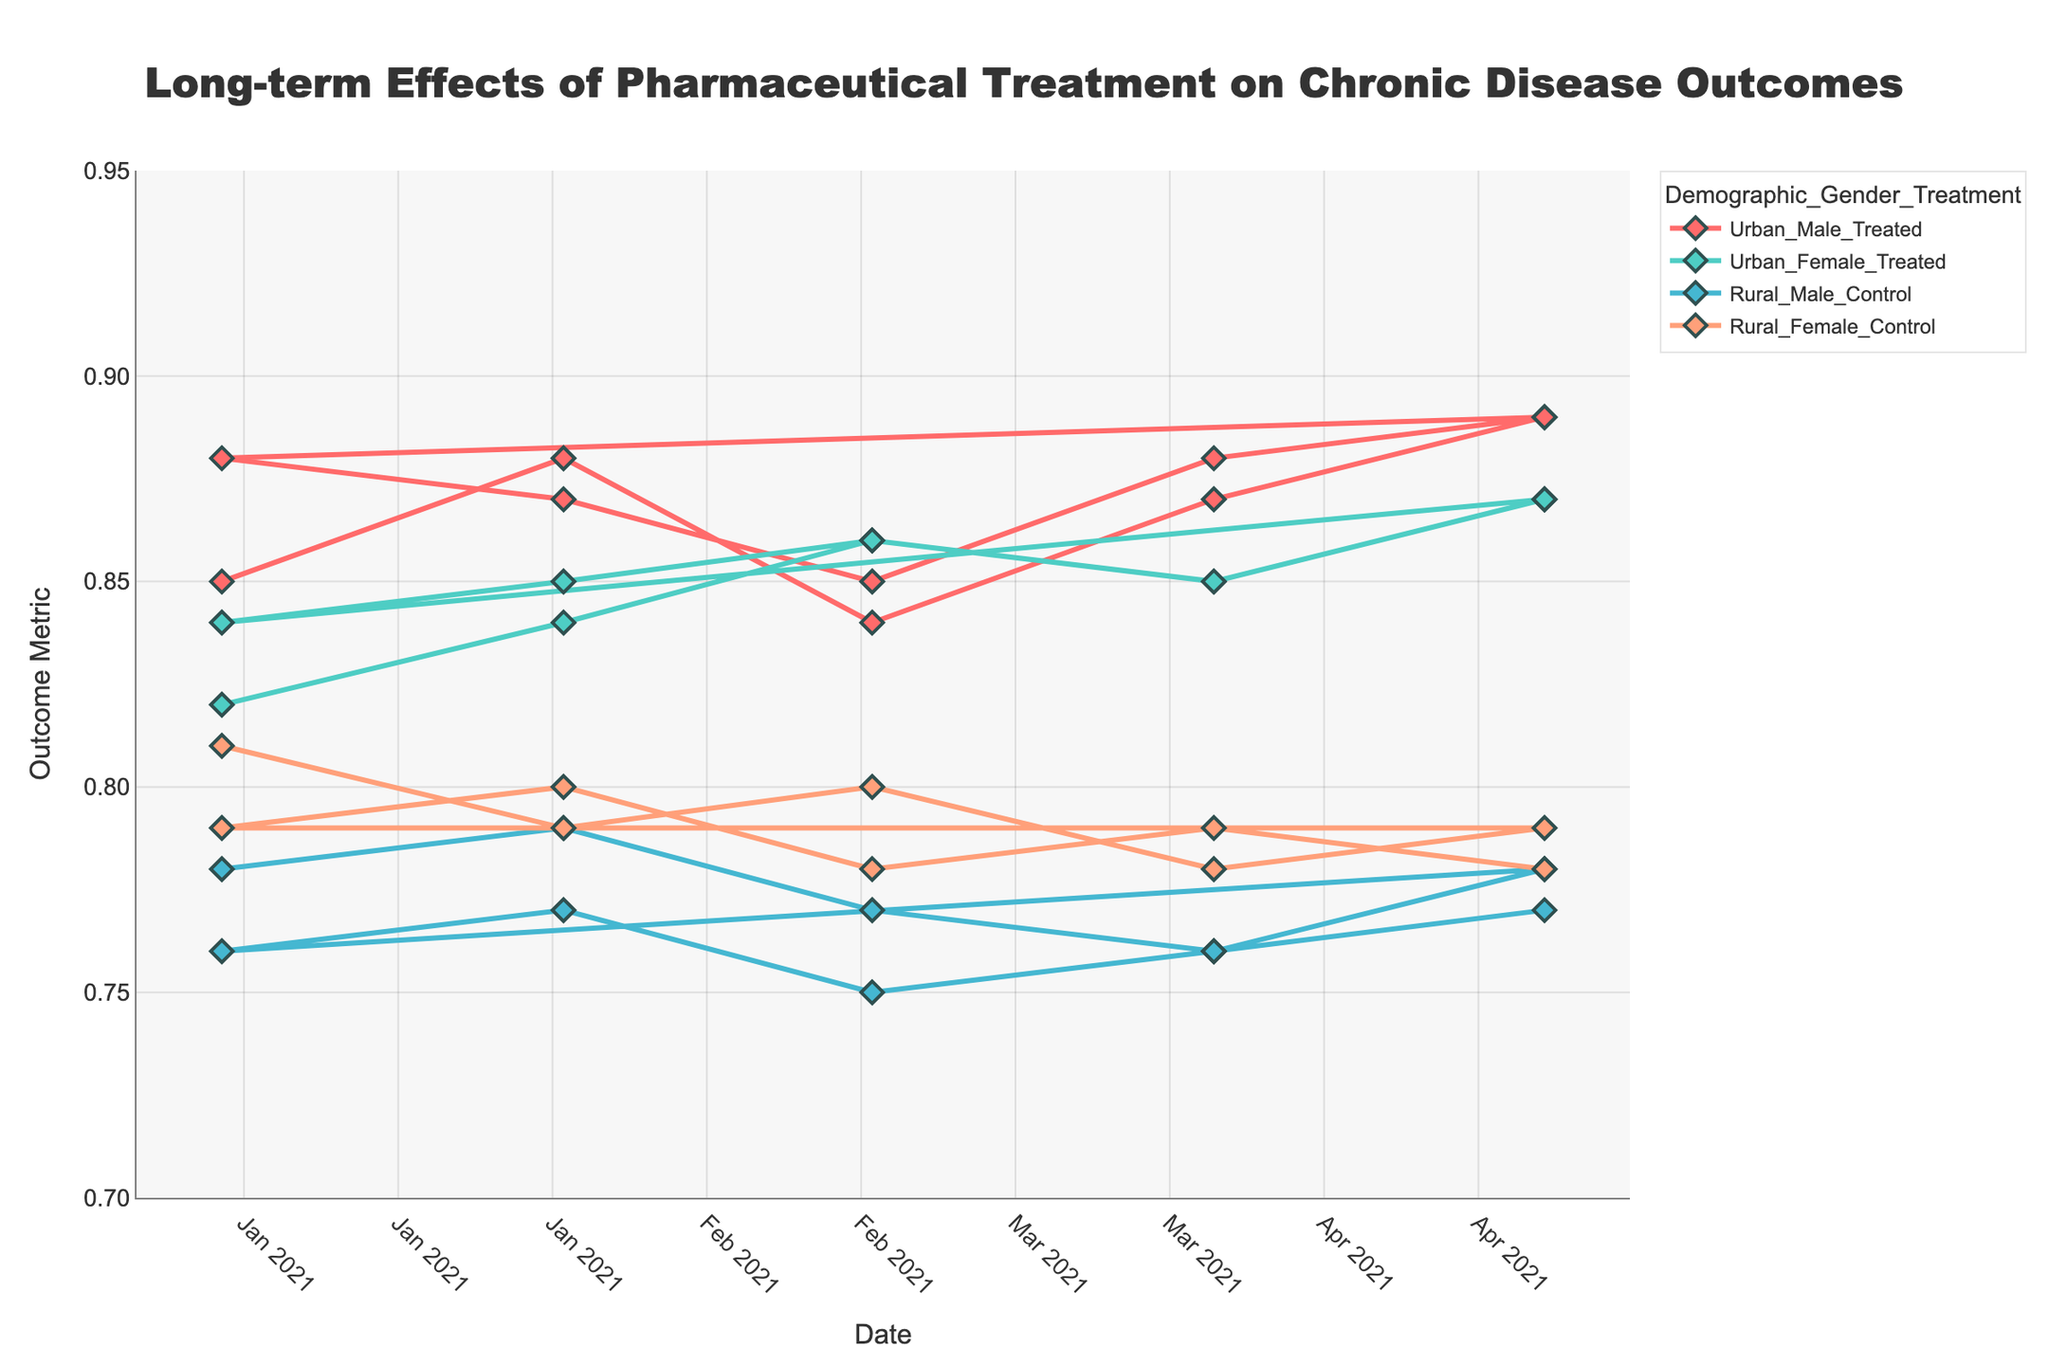What's the title of the figure? The title is usually placed at the top of the figure, and in this case, it reads, "Long-term Effects of Pharmaceutical Treatment on Chronic Disease Outcomes."
Answer: Long-term Effects of Pharmaceutical Treatment on Chronic Disease Outcomes What does the x-axis represent? The x-axis represents the timeline, specifically the dates ranging from January 2021 to May 2021 as shown by the tick marks.
Answer: Date Which group has the highest Outcome Metric value in May 2021? By looking at the data points for May 2021, we can see that the 'Urban_Male_Treated' group has the highest Outcome Metric value of 0.89.
Answer: Urban_Male_Treated How does the Outcome Metric for Urban_Male_Treated change over time? By following the 'Urban_Male_Treated' line, we see the values: 0.85 (January), 0.88 (February), 0.84 (March), 0.87 (April), 0.89 (May). The Outcome Metric oscillates slightly but generally shows an increasing trend.
Answer: Generally increasing Which group shows a decreasing trend in Outcome Metric over the time period? The 'Rural_Male_Control' group shows a decreasing trend in Outcome Metric from 0.78 (January) to 0.77 (February), 0.75 (March), 0.76 (April), and remaining at 0.77 (May).
Answer: Rural_Male_Control What’s the average Outcome Metric for Urban Female Treated group from January to May 2021? Calculating the average involves summing the values for the 'Urban_Female_Treated' group and dividing by the number of data points: (0.82 + 0.84 + 0.86 + 0.85 + 0.87) / 5 = 4.24 / 5 = 0.848
Answer: 0.848 Compare the initial and final values of the Outcome Metric for Rural Female Control group. The values for 'Rural_Female_Control' in January are 0.81 and in May are 0.79. Thus, the Outcome Metric decreased by 0.02 points over the period.
Answer: Decreased by 0.02 Which group has the most volatile Outcome Metric values over time? Volatility can be seen in fluctuations. The 'Urban_Male_Treated' group shows the most volatility with values: 0.85, 0.88, 0.84, 0.87, 0.89, experiencing an overall larger range of changes.
Answer: Urban_Male_Treated Are there any groups with the same Outcome Metric value in consecutive months? By looking at the data, we see that 'Rural_Male_Control' has the same value (0.78) in both January and May 2021.
Answer: Rural_Male_Control in January and May What's the color of the line representing Urban Female Treated group? The color palette assigns a specific color to each group. The 'Urban_Female_Treated' group is represented by a cyan-like color or '#4ECDC4'.
Answer: Cyan 